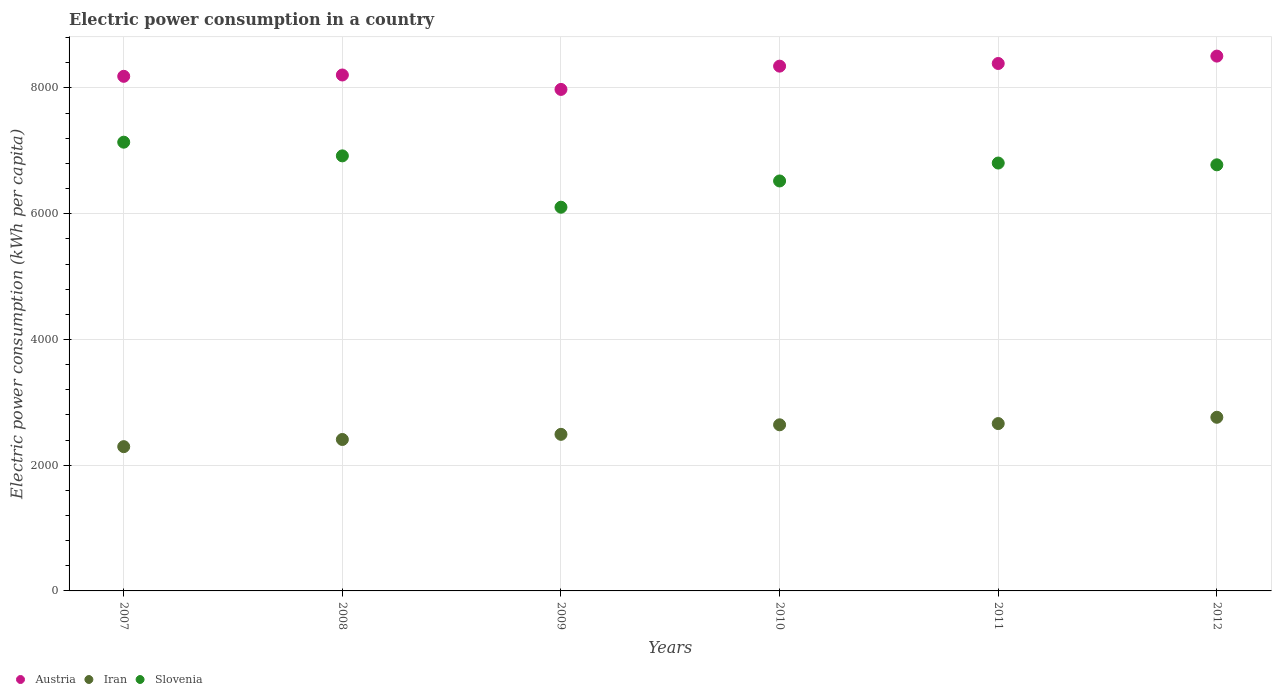Is the number of dotlines equal to the number of legend labels?
Make the answer very short. Yes. What is the electric power consumption in in Slovenia in 2007?
Offer a very short reply. 7137.82. Across all years, what is the maximum electric power consumption in in Iran?
Keep it short and to the point. 2762.06. Across all years, what is the minimum electric power consumption in in Austria?
Offer a very short reply. 7977.28. What is the total electric power consumption in in Iran in the graph?
Offer a terse response. 1.53e+04. What is the difference between the electric power consumption in in Slovenia in 2009 and that in 2010?
Ensure brevity in your answer.  -417.65. What is the difference between the electric power consumption in in Slovenia in 2011 and the electric power consumption in in Austria in 2008?
Make the answer very short. -1400.53. What is the average electric power consumption in in Iran per year?
Your answer should be compact. 2543.46. In the year 2009, what is the difference between the electric power consumption in in Slovenia and electric power consumption in in Austria?
Your answer should be compact. -1873.84. What is the ratio of the electric power consumption in in Iran in 2009 to that in 2011?
Ensure brevity in your answer.  0.94. What is the difference between the highest and the second highest electric power consumption in in Iran?
Keep it short and to the point. 100.15. What is the difference between the highest and the lowest electric power consumption in in Iran?
Offer a terse response. 467.13. Is it the case that in every year, the sum of the electric power consumption in in Austria and electric power consumption in in Iran  is greater than the electric power consumption in in Slovenia?
Keep it short and to the point. Yes. Does the electric power consumption in in Slovenia monotonically increase over the years?
Ensure brevity in your answer.  No. Is the electric power consumption in in Iran strictly greater than the electric power consumption in in Slovenia over the years?
Your response must be concise. No. Are the values on the major ticks of Y-axis written in scientific E-notation?
Give a very brief answer. No. Does the graph contain any zero values?
Offer a terse response. No. How are the legend labels stacked?
Make the answer very short. Horizontal. What is the title of the graph?
Make the answer very short. Electric power consumption in a country. What is the label or title of the X-axis?
Provide a succinct answer. Years. What is the label or title of the Y-axis?
Provide a short and direct response. Electric power consumption (kWh per capita). What is the Electric power consumption (kWh per capita) of Austria in 2007?
Offer a terse response. 8185.54. What is the Electric power consumption (kWh per capita) in Iran in 2007?
Make the answer very short. 2294.93. What is the Electric power consumption (kWh per capita) in Slovenia in 2007?
Your response must be concise. 7137.82. What is the Electric power consumption (kWh per capita) in Austria in 2008?
Your response must be concise. 8206.7. What is the Electric power consumption (kWh per capita) in Iran in 2008?
Ensure brevity in your answer.  2408.88. What is the Electric power consumption (kWh per capita) of Slovenia in 2008?
Your answer should be very brief. 6920.24. What is the Electric power consumption (kWh per capita) in Austria in 2009?
Your response must be concise. 7977.28. What is the Electric power consumption (kWh per capita) in Iran in 2009?
Your response must be concise. 2490.62. What is the Electric power consumption (kWh per capita) of Slovenia in 2009?
Give a very brief answer. 6103.44. What is the Electric power consumption (kWh per capita) of Austria in 2010?
Provide a short and direct response. 8347.44. What is the Electric power consumption (kWh per capita) of Iran in 2010?
Make the answer very short. 2642.37. What is the Electric power consumption (kWh per capita) in Slovenia in 2010?
Your answer should be compact. 6521.09. What is the Electric power consumption (kWh per capita) in Austria in 2011?
Give a very brief answer. 8389.66. What is the Electric power consumption (kWh per capita) of Iran in 2011?
Your answer should be very brief. 2661.91. What is the Electric power consumption (kWh per capita) in Slovenia in 2011?
Ensure brevity in your answer.  6806.17. What is the Electric power consumption (kWh per capita) of Austria in 2012?
Your answer should be compact. 8507.13. What is the Electric power consumption (kWh per capita) in Iran in 2012?
Provide a succinct answer. 2762.06. What is the Electric power consumption (kWh per capita) of Slovenia in 2012?
Give a very brief answer. 6777.79. Across all years, what is the maximum Electric power consumption (kWh per capita) in Austria?
Keep it short and to the point. 8507.13. Across all years, what is the maximum Electric power consumption (kWh per capita) in Iran?
Keep it short and to the point. 2762.06. Across all years, what is the maximum Electric power consumption (kWh per capita) of Slovenia?
Ensure brevity in your answer.  7137.82. Across all years, what is the minimum Electric power consumption (kWh per capita) of Austria?
Offer a very short reply. 7977.28. Across all years, what is the minimum Electric power consumption (kWh per capita) in Iran?
Your answer should be compact. 2294.93. Across all years, what is the minimum Electric power consumption (kWh per capita) in Slovenia?
Make the answer very short. 6103.44. What is the total Electric power consumption (kWh per capita) of Austria in the graph?
Ensure brevity in your answer.  4.96e+04. What is the total Electric power consumption (kWh per capita) of Iran in the graph?
Make the answer very short. 1.53e+04. What is the total Electric power consumption (kWh per capita) of Slovenia in the graph?
Provide a succinct answer. 4.03e+04. What is the difference between the Electric power consumption (kWh per capita) in Austria in 2007 and that in 2008?
Make the answer very short. -21.16. What is the difference between the Electric power consumption (kWh per capita) of Iran in 2007 and that in 2008?
Offer a very short reply. -113.96. What is the difference between the Electric power consumption (kWh per capita) in Slovenia in 2007 and that in 2008?
Your answer should be compact. 217.58. What is the difference between the Electric power consumption (kWh per capita) of Austria in 2007 and that in 2009?
Your response must be concise. 208.26. What is the difference between the Electric power consumption (kWh per capita) in Iran in 2007 and that in 2009?
Make the answer very short. -195.69. What is the difference between the Electric power consumption (kWh per capita) of Slovenia in 2007 and that in 2009?
Ensure brevity in your answer.  1034.38. What is the difference between the Electric power consumption (kWh per capita) of Austria in 2007 and that in 2010?
Your answer should be compact. -161.9. What is the difference between the Electric power consumption (kWh per capita) of Iran in 2007 and that in 2010?
Keep it short and to the point. -347.45. What is the difference between the Electric power consumption (kWh per capita) in Slovenia in 2007 and that in 2010?
Provide a succinct answer. 616.73. What is the difference between the Electric power consumption (kWh per capita) of Austria in 2007 and that in 2011?
Provide a succinct answer. -204.12. What is the difference between the Electric power consumption (kWh per capita) in Iran in 2007 and that in 2011?
Your response must be concise. -366.99. What is the difference between the Electric power consumption (kWh per capita) of Slovenia in 2007 and that in 2011?
Offer a terse response. 331.65. What is the difference between the Electric power consumption (kWh per capita) in Austria in 2007 and that in 2012?
Your answer should be very brief. -321.59. What is the difference between the Electric power consumption (kWh per capita) in Iran in 2007 and that in 2012?
Offer a terse response. -467.13. What is the difference between the Electric power consumption (kWh per capita) of Slovenia in 2007 and that in 2012?
Ensure brevity in your answer.  360.03. What is the difference between the Electric power consumption (kWh per capita) in Austria in 2008 and that in 2009?
Offer a terse response. 229.42. What is the difference between the Electric power consumption (kWh per capita) of Iran in 2008 and that in 2009?
Your response must be concise. -81.73. What is the difference between the Electric power consumption (kWh per capita) of Slovenia in 2008 and that in 2009?
Ensure brevity in your answer.  816.8. What is the difference between the Electric power consumption (kWh per capita) in Austria in 2008 and that in 2010?
Keep it short and to the point. -140.74. What is the difference between the Electric power consumption (kWh per capita) of Iran in 2008 and that in 2010?
Keep it short and to the point. -233.49. What is the difference between the Electric power consumption (kWh per capita) of Slovenia in 2008 and that in 2010?
Your response must be concise. 399.15. What is the difference between the Electric power consumption (kWh per capita) in Austria in 2008 and that in 2011?
Your answer should be compact. -182.96. What is the difference between the Electric power consumption (kWh per capita) of Iran in 2008 and that in 2011?
Your response must be concise. -253.03. What is the difference between the Electric power consumption (kWh per capita) in Slovenia in 2008 and that in 2011?
Offer a terse response. 114.07. What is the difference between the Electric power consumption (kWh per capita) of Austria in 2008 and that in 2012?
Offer a very short reply. -300.43. What is the difference between the Electric power consumption (kWh per capita) of Iran in 2008 and that in 2012?
Your answer should be very brief. -353.17. What is the difference between the Electric power consumption (kWh per capita) in Slovenia in 2008 and that in 2012?
Offer a terse response. 142.45. What is the difference between the Electric power consumption (kWh per capita) in Austria in 2009 and that in 2010?
Give a very brief answer. -370.16. What is the difference between the Electric power consumption (kWh per capita) of Iran in 2009 and that in 2010?
Offer a very short reply. -151.75. What is the difference between the Electric power consumption (kWh per capita) in Slovenia in 2009 and that in 2010?
Your response must be concise. -417.65. What is the difference between the Electric power consumption (kWh per capita) of Austria in 2009 and that in 2011?
Your answer should be very brief. -412.38. What is the difference between the Electric power consumption (kWh per capita) of Iran in 2009 and that in 2011?
Your answer should be very brief. -171.29. What is the difference between the Electric power consumption (kWh per capita) in Slovenia in 2009 and that in 2011?
Your answer should be compact. -702.73. What is the difference between the Electric power consumption (kWh per capita) in Austria in 2009 and that in 2012?
Ensure brevity in your answer.  -529.85. What is the difference between the Electric power consumption (kWh per capita) of Iran in 2009 and that in 2012?
Offer a terse response. -271.44. What is the difference between the Electric power consumption (kWh per capita) in Slovenia in 2009 and that in 2012?
Your answer should be very brief. -674.35. What is the difference between the Electric power consumption (kWh per capita) in Austria in 2010 and that in 2011?
Provide a succinct answer. -42.22. What is the difference between the Electric power consumption (kWh per capita) in Iran in 2010 and that in 2011?
Offer a terse response. -19.54. What is the difference between the Electric power consumption (kWh per capita) of Slovenia in 2010 and that in 2011?
Provide a short and direct response. -285.08. What is the difference between the Electric power consumption (kWh per capita) of Austria in 2010 and that in 2012?
Your response must be concise. -159.69. What is the difference between the Electric power consumption (kWh per capita) of Iran in 2010 and that in 2012?
Your answer should be compact. -119.69. What is the difference between the Electric power consumption (kWh per capita) of Slovenia in 2010 and that in 2012?
Make the answer very short. -256.7. What is the difference between the Electric power consumption (kWh per capita) in Austria in 2011 and that in 2012?
Your answer should be compact. -117.47. What is the difference between the Electric power consumption (kWh per capita) in Iran in 2011 and that in 2012?
Give a very brief answer. -100.15. What is the difference between the Electric power consumption (kWh per capita) in Slovenia in 2011 and that in 2012?
Your answer should be very brief. 28.38. What is the difference between the Electric power consumption (kWh per capita) in Austria in 2007 and the Electric power consumption (kWh per capita) in Iran in 2008?
Keep it short and to the point. 5776.65. What is the difference between the Electric power consumption (kWh per capita) in Austria in 2007 and the Electric power consumption (kWh per capita) in Slovenia in 2008?
Provide a succinct answer. 1265.29. What is the difference between the Electric power consumption (kWh per capita) in Iran in 2007 and the Electric power consumption (kWh per capita) in Slovenia in 2008?
Make the answer very short. -4625.32. What is the difference between the Electric power consumption (kWh per capita) in Austria in 2007 and the Electric power consumption (kWh per capita) in Iran in 2009?
Keep it short and to the point. 5694.92. What is the difference between the Electric power consumption (kWh per capita) of Austria in 2007 and the Electric power consumption (kWh per capita) of Slovenia in 2009?
Provide a short and direct response. 2082.09. What is the difference between the Electric power consumption (kWh per capita) of Iran in 2007 and the Electric power consumption (kWh per capita) of Slovenia in 2009?
Provide a succinct answer. -3808.52. What is the difference between the Electric power consumption (kWh per capita) in Austria in 2007 and the Electric power consumption (kWh per capita) in Iran in 2010?
Make the answer very short. 5543.16. What is the difference between the Electric power consumption (kWh per capita) of Austria in 2007 and the Electric power consumption (kWh per capita) of Slovenia in 2010?
Make the answer very short. 1664.44. What is the difference between the Electric power consumption (kWh per capita) in Iran in 2007 and the Electric power consumption (kWh per capita) in Slovenia in 2010?
Give a very brief answer. -4226.17. What is the difference between the Electric power consumption (kWh per capita) in Austria in 2007 and the Electric power consumption (kWh per capita) in Iran in 2011?
Offer a terse response. 5523.62. What is the difference between the Electric power consumption (kWh per capita) of Austria in 2007 and the Electric power consumption (kWh per capita) of Slovenia in 2011?
Your answer should be compact. 1379.36. What is the difference between the Electric power consumption (kWh per capita) of Iran in 2007 and the Electric power consumption (kWh per capita) of Slovenia in 2011?
Your answer should be compact. -4511.25. What is the difference between the Electric power consumption (kWh per capita) in Austria in 2007 and the Electric power consumption (kWh per capita) in Iran in 2012?
Your response must be concise. 5423.48. What is the difference between the Electric power consumption (kWh per capita) in Austria in 2007 and the Electric power consumption (kWh per capita) in Slovenia in 2012?
Provide a short and direct response. 1407.74. What is the difference between the Electric power consumption (kWh per capita) in Iran in 2007 and the Electric power consumption (kWh per capita) in Slovenia in 2012?
Offer a very short reply. -4482.87. What is the difference between the Electric power consumption (kWh per capita) of Austria in 2008 and the Electric power consumption (kWh per capita) of Iran in 2009?
Offer a very short reply. 5716.08. What is the difference between the Electric power consumption (kWh per capita) in Austria in 2008 and the Electric power consumption (kWh per capita) in Slovenia in 2009?
Your response must be concise. 2103.26. What is the difference between the Electric power consumption (kWh per capita) in Iran in 2008 and the Electric power consumption (kWh per capita) in Slovenia in 2009?
Make the answer very short. -3694.56. What is the difference between the Electric power consumption (kWh per capita) in Austria in 2008 and the Electric power consumption (kWh per capita) in Iran in 2010?
Your answer should be very brief. 5564.33. What is the difference between the Electric power consumption (kWh per capita) of Austria in 2008 and the Electric power consumption (kWh per capita) of Slovenia in 2010?
Give a very brief answer. 1685.6. What is the difference between the Electric power consumption (kWh per capita) in Iran in 2008 and the Electric power consumption (kWh per capita) in Slovenia in 2010?
Offer a very short reply. -4112.21. What is the difference between the Electric power consumption (kWh per capita) of Austria in 2008 and the Electric power consumption (kWh per capita) of Iran in 2011?
Offer a very short reply. 5544.79. What is the difference between the Electric power consumption (kWh per capita) of Austria in 2008 and the Electric power consumption (kWh per capita) of Slovenia in 2011?
Your response must be concise. 1400.53. What is the difference between the Electric power consumption (kWh per capita) in Iran in 2008 and the Electric power consumption (kWh per capita) in Slovenia in 2011?
Offer a terse response. -4397.29. What is the difference between the Electric power consumption (kWh per capita) of Austria in 2008 and the Electric power consumption (kWh per capita) of Iran in 2012?
Your answer should be very brief. 5444.64. What is the difference between the Electric power consumption (kWh per capita) in Austria in 2008 and the Electric power consumption (kWh per capita) in Slovenia in 2012?
Provide a succinct answer. 1428.9. What is the difference between the Electric power consumption (kWh per capita) of Iran in 2008 and the Electric power consumption (kWh per capita) of Slovenia in 2012?
Provide a short and direct response. -4368.91. What is the difference between the Electric power consumption (kWh per capita) of Austria in 2009 and the Electric power consumption (kWh per capita) of Iran in 2010?
Give a very brief answer. 5334.91. What is the difference between the Electric power consumption (kWh per capita) in Austria in 2009 and the Electric power consumption (kWh per capita) in Slovenia in 2010?
Give a very brief answer. 1456.18. What is the difference between the Electric power consumption (kWh per capita) of Iran in 2009 and the Electric power consumption (kWh per capita) of Slovenia in 2010?
Your response must be concise. -4030.48. What is the difference between the Electric power consumption (kWh per capita) of Austria in 2009 and the Electric power consumption (kWh per capita) of Iran in 2011?
Your answer should be compact. 5315.37. What is the difference between the Electric power consumption (kWh per capita) of Austria in 2009 and the Electric power consumption (kWh per capita) of Slovenia in 2011?
Your answer should be compact. 1171.11. What is the difference between the Electric power consumption (kWh per capita) in Iran in 2009 and the Electric power consumption (kWh per capita) in Slovenia in 2011?
Ensure brevity in your answer.  -4315.55. What is the difference between the Electric power consumption (kWh per capita) in Austria in 2009 and the Electric power consumption (kWh per capita) in Iran in 2012?
Your answer should be very brief. 5215.22. What is the difference between the Electric power consumption (kWh per capita) of Austria in 2009 and the Electric power consumption (kWh per capita) of Slovenia in 2012?
Your response must be concise. 1199.48. What is the difference between the Electric power consumption (kWh per capita) of Iran in 2009 and the Electric power consumption (kWh per capita) of Slovenia in 2012?
Offer a very short reply. -4287.18. What is the difference between the Electric power consumption (kWh per capita) of Austria in 2010 and the Electric power consumption (kWh per capita) of Iran in 2011?
Ensure brevity in your answer.  5685.53. What is the difference between the Electric power consumption (kWh per capita) of Austria in 2010 and the Electric power consumption (kWh per capita) of Slovenia in 2011?
Your answer should be compact. 1541.27. What is the difference between the Electric power consumption (kWh per capita) in Iran in 2010 and the Electric power consumption (kWh per capita) in Slovenia in 2011?
Your response must be concise. -4163.8. What is the difference between the Electric power consumption (kWh per capita) in Austria in 2010 and the Electric power consumption (kWh per capita) in Iran in 2012?
Ensure brevity in your answer.  5585.38. What is the difference between the Electric power consumption (kWh per capita) of Austria in 2010 and the Electric power consumption (kWh per capita) of Slovenia in 2012?
Your response must be concise. 1569.64. What is the difference between the Electric power consumption (kWh per capita) in Iran in 2010 and the Electric power consumption (kWh per capita) in Slovenia in 2012?
Give a very brief answer. -4135.42. What is the difference between the Electric power consumption (kWh per capita) of Austria in 2011 and the Electric power consumption (kWh per capita) of Iran in 2012?
Make the answer very short. 5627.6. What is the difference between the Electric power consumption (kWh per capita) in Austria in 2011 and the Electric power consumption (kWh per capita) in Slovenia in 2012?
Offer a terse response. 1611.86. What is the difference between the Electric power consumption (kWh per capita) of Iran in 2011 and the Electric power consumption (kWh per capita) of Slovenia in 2012?
Provide a short and direct response. -4115.88. What is the average Electric power consumption (kWh per capita) of Austria per year?
Offer a terse response. 8268.96. What is the average Electric power consumption (kWh per capita) in Iran per year?
Keep it short and to the point. 2543.46. What is the average Electric power consumption (kWh per capita) of Slovenia per year?
Keep it short and to the point. 6711.09. In the year 2007, what is the difference between the Electric power consumption (kWh per capita) in Austria and Electric power consumption (kWh per capita) in Iran?
Ensure brevity in your answer.  5890.61. In the year 2007, what is the difference between the Electric power consumption (kWh per capita) in Austria and Electric power consumption (kWh per capita) in Slovenia?
Offer a terse response. 1047.71. In the year 2007, what is the difference between the Electric power consumption (kWh per capita) of Iran and Electric power consumption (kWh per capita) of Slovenia?
Ensure brevity in your answer.  -4842.9. In the year 2008, what is the difference between the Electric power consumption (kWh per capita) of Austria and Electric power consumption (kWh per capita) of Iran?
Offer a very short reply. 5797.81. In the year 2008, what is the difference between the Electric power consumption (kWh per capita) in Austria and Electric power consumption (kWh per capita) in Slovenia?
Provide a short and direct response. 1286.45. In the year 2008, what is the difference between the Electric power consumption (kWh per capita) in Iran and Electric power consumption (kWh per capita) in Slovenia?
Give a very brief answer. -4511.36. In the year 2009, what is the difference between the Electric power consumption (kWh per capita) of Austria and Electric power consumption (kWh per capita) of Iran?
Provide a short and direct response. 5486.66. In the year 2009, what is the difference between the Electric power consumption (kWh per capita) in Austria and Electric power consumption (kWh per capita) in Slovenia?
Provide a short and direct response. 1873.84. In the year 2009, what is the difference between the Electric power consumption (kWh per capita) of Iran and Electric power consumption (kWh per capita) of Slovenia?
Keep it short and to the point. -3612.82. In the year 2010, what is the difference between the Electric power consumption (kWh per capita) of Austria and Electric power consumption (kWh per capita) of Iran?
Your answer should be compact. 5705.07. In the year 2010, what is the difference between the Electric power consumption (kWh per capita) in Austria and Electric power consumption (kWh per capita) in Slovenia?
Make the answer very short. 1826.35. In the year 2010, what is the difference between the Electric power consumption (kWh per capita) in Iran and Electric power consumption (kWh per capita) in Slovenia?
Give a very brief answer. -3878.72. In the year 2011, what is the difference between the Electric power consumption (kWh per capita) of Austria and Electric power consumption (kWh per capita) of Iran?
Your answer should be compact. 5727.74. In the year 2011, what is the difference between the Electric power consumption (kWh per capita) of Austria and Electric power consumption (kWh per capita) of Slovenia?
Your answer should be compact. 1583.49. In the year 2011, what is the difference between the Electric power consumption (kWh per capita) of Iran and Electric power consumption (kWh per capita) of Slovenia?
Provide a succinct answer. -4144.26. In the year 2012, what is the difference between the Electric power consumption (kWh per capita) of Austria and Electric power consumption (kWh per capita) of Iran?
Your answer should be compact. 5745.07. In the year 2012, what is the difference between the Electric power consumption (kWh per capita) in Austria and Electric power consumption (kWh per capita) in Slovenia?
Your answer should be very brief. 1729.33. In the year 2012, what is the difference between the Electric power consumption (kWh per capita) in Iran and Electric power consumption (kWh per capita) in Slovenia?
Provide a short and direct response. -4015.74. What is the ratio of the Electric power consumption (kWh per capita) of Austria in 2007 to that in 2008?
Ensure brevity in your answer.  1. What is the ratio of the Electric power consumption (kWh per capita) in Iran in 2007 to that in 2008?
Offer a very short reply. 0.95. What is the ratio of the Electric power consumption (kWh per capita) of Slovenia in 2007 to that in 2008?
Provide a short and direct response. 1.03. What is the ratio of the Electric power consumption (kWh per capita) in Austria in 2007 to that in 2009?
Your answer should be compact. 1.03. What is the ratio of the Electric power consumption (kWh per capita) in Iran in 2007 to that in 2009?
Your answer should be very brief. 0.92. What is the ratio of the Electric power consumption (kWh per capita) of Slovenia in 2007 to that in 2009?
Provide a succinct answer. 1.17. What is the ratio of the Electric power consumption (kWh per capita) in Austria in 2007 to that in 2010?
Make the answer very short. 0.98. What is the ratio of the Electric power consumption (kWh per capita) of Iran in 2007 to that in 2010?
Your answer should be very brief. 0.87. What is the ratio of the Electric power consumption (kWh per capita) of Slovenia in 2007 to that in 2010?
Keep it short and to the point. 1.09. What is the ratio of the Electric power consumption (kWh per capita) of Austria in 2007 to that in 2011?
Keep it short and to the point. 0.98. What is the ratio of the Electric power consumption (kWh per capita) in Iran in 2007 to that in 2011?
Provide a short and direct response. 0.86. What is the ratio of the Electric power consumption (kWh per capita) in Slovenia in 2007 to that in 2011?
Provide a short and direct response. 1.05. What is the ratio of the Electric power consumption (kWh per capita) of Austria in 2007 to that in 2012?
Ensure brevity in your answer.  0.96. What is the ratio of the Electric power consumption (kWh per capita) of Iran in 2007 to that in 2012?
Give a very brief answer. 0.83. What is the ratio of the Electric power consumption (kWh per capita) of Slovenia in 2007 to that in 2012?
Make the answer very short. 1.05. What is the ratio of the Electric power consumption (kWh per capita) of Austria in 2008 to that in 2009?
Make the answer very short. 1.03. What is the ratio of the Electric power consumption (kWh per capita) in Iran in 2008 to that in 2009?
Give a very brief answer. 0.97. What is the ratio of the Electric power consumption (kWh per capita) of Slovenia in 2008 to that in 2009?
Provide a succinct answer. 1.13. What is the ratio of the Electric power consumption (kWh per capita) in Austria in 2008 to that in 2010?
Your answer should be very brief. 0.98. What is the ratio of the Electric power consumption (kWh per capita) of Iran in 2008 to that in 2010?
Make the answer very short. 0.91. What is the ratio of the Electric power consumption (kWh per capita) in Slovenia in 2008 to that in 2010?
Your answer should be compact. 1.06. What is the ratio of the Electric power consumption (kWh per capita) of Austria in 2008 to that in 2011?
Give a very brief answer. 0.98. What is the ratio of the Electric power consumption (kWh per capita) of Iran in 2008 to that in 2011?
Give a very brief answer. 0.9. What is the ratio of the Electric power consumption (kWh per capita) in Slovenia in 2008 to that in 2011?
Your answer should be compact. 1.02. What is the ratio of the Electric power consumption (kWh per capita) of Austria in 2008 to that in 2012?
Your answer should be very brief. 0.96. What is the ratio of the Electric power consumption (kWh per capita) in Iran in 2008 to that in 2012?
Ensure brevity in your answer.  0.87. What is the ratio of the Electric power consumption (kWh per capita) of Austria in 2009 to that in 2010?
Offer a terse response. 0.96. What is the ratio of the Electric power consumption (kWh per capita) of Iran in 2009 to that in 2010?
Your response must be concise. 0.94. What is the ratio of the Electric power consumption (kWh per capita) in Slovenia in 2009 to that in 2010?
Make the answer very short. 0.94. What is the ratio of the Electric power consumption (kWh per capita) of Austria in 2009 to that in 2011?
Your response must be concise. 0.95. What is the ratio of the Electric power consumption (kWh per capita) in Iran in 2009 to that in 2011?
Your answer should be compact. 0.94. What is the ratio of the Electric power consumption (kWh per capita) of Slovenia in 2009 to that in 2011?
Give a very brief answer. 0.9. What is the ratio of the Electric power consumption (kWh per capita) of Austria in 2009 to that in 2012?
Provide a succinct answer. 0.94. What is the ratio of the Electric power consumption (kWh per capita) in Iran in 2009 to that in 2012?
Offer a very short reply. 0.9. What is the ratio of the Electric power consumption (kWh per capita) of Slovenia in 2009 to that in 2012?
Offer a very short reply. 0.9. What is the ratio of the Electric power consumption (kWh per capita) in Slovenia in 2010 to that in 2011?
Keep it short and to the point. 0.96. What is the ratio of the Electric power consumption (kWh per capita) in Austria in 2010 to that in 2012?
Your answer should be compact. 0.98. What is the ratio of the Electric power consumption (kWh per capita) of Iran in 2010 to that in 2012?
Offer a terse response. 0.96. What is the ratio of the Electric power consumption (kWh per capita) of Slovenia in 2010 to that in 2012?
Your answer should be very brief. 0.96. What is the ratio of the Electric power consumption (kWh per capita) in Austria in 2011 to that in 2012?
Offer a very short reply. 0.99. What is the ratio of the Electric power consumption (kWh per capita) in Iran in 2011 to that in 2012?
Offer a terse response. 0.96. What is the ratio of the Electric power consumption (kWh per capita) in Slovenia in 2011 to that in 2012?
Your answer should be very brief. 1. What is the difference between the highest and the second highest Electric power consumption (kWh per capita) of Austria?
Ensure brevity in your answer.  117.47. What is the difference between the highest and the second highest Electric power consumption (kWh per capita) in Iran?
Your answer should be compact. 100.15. What is the difference between the highest and the second highest Electric power consumption (kWh per capita) of Slovenia?
Your answer should be compact. 217.58. What is the difference between the highest and the lowest Electric power consumption (kWh per capita) of Austria?
Your answer should be compact. 529.85. What is the difference between the highest and the lowest Electric power consumption (kWh per capita) of Iran?
Your answer should be very brief. 467.13. What is the difference between the highest and the lowest Electric power consumption (kWh per capita) in Slovenia?
Offer a very short reply. 1034.38. 